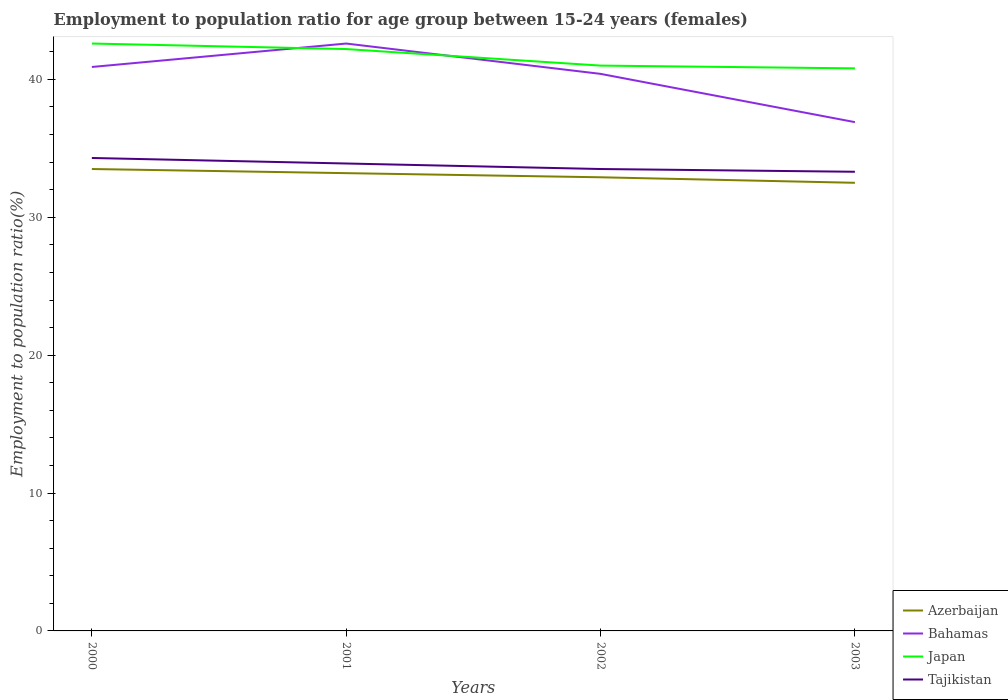How many different coloured lines are there?
Your response must be concise. 4. Does the line corresponding to Azerbaijan intersect with the line corresponding to Japan?
Provide a short and direct response. No. Is the number of lines equal to the number of legend labels?
Keep it short and to the point. Yes. Across all years, what is the maximum employment to population ratio in Bahamas?
Ensure brevity in your answer.  36.9. In which year was the employment to population ratio in Azerbaijan maximum?
Your answer should be compact. 2003. What is the total employment to population ratio in Japan in the graph?
Give a very brief answer. 1.2. What is the difference between the highest and the second highest employment to population ratio in Tajikistan?
Provide a succinct answer. 1. What is the difference between the highest and the lowest employment to population ratio in Azerbaijan?
Keep it short and to the point. 2. Is the employment to population ratio in Azerbaijan strictly greater than the employment to population ratio in Tajikistan over the years?
Your response must be concise. Yes. How many years are there in the graph?
Give a very brief answer. 4. What is the difference between two consecutive major ticks on the Y-axis?
Ensure brevity in your answer.  10. How many legend labels are there?
Your response must be concise. 4. What is the title of the graph?
Offer a terse response. Employment to population ratio for age group between 15-24 years (females). What is the label or title of the X-axis?
Provide a succinct answer. Years. What is the label or title of the Y-axis?
Make the answer very short. Employment to population ratio(%). What is the Employment to population ratio(%) in Azerbaijan in 2000?
Ensure brevity in your answer.  33.5. What is the Employment to population ratio(%) in Bahamas in 2000?
Give a very brief answer. 40.9. What is the Employment to population ratio(%) in Japan in 2000?
Make the answer very short. 42.6. What is the Employment to population ratio(%) of Tajikistan in 2000?
Give a very brief answer. 34.3. What is the Employment to population ratio(%) in Azerbaijan in 2001?
Ensure brevity in your answer.  33.2. What is the Employment to population ratio(%) of Bahamas in 2001?
Your response must be concise. 42.6. What is the Employment to population ratio(%) in Japan in 2001?
Your response must be concise. 42.2. What is the Employment to population ratio(%) of Tajikistan in 2001?
Make the answer very short. 33.9. What is the Employment to population ratio(%) in Azerbaijan in 2002?
Keep it short and to the point. 32.9. What is the Employment to population ratio(%) of Bahamas in 2002?
Offer a very short reply. 40.4. What is the Employment to population ratio(%) in Tajikistan in 2002?
Your response must be concise. 33.5. What is the Employment to population ratio(%) in Azerbaijan in 2003?
Keep it short and to the point. 32.5. What is the Employment to population ratio(%) of Bahamas in 2003?
Offer a very short reply. 36.9. What is the Employment to population ratio(%) in Japan in 2003?
Make the answer very short. 40.8. What is the Employment to population ratio(%) of Tajikistan in 2003?
Give a very brief answer. 33.3. Across all years, what is the maximum Employment to population ratio(%) in Azerbaijan?
Offer a very short reply. 33.5. Across all years, what is the maximum Employment to population ratio(%) in Bahamas?
Offer a very short reply. 42.6. Across all years, what is the maximum Employment to population ratio(%) in Japan?
Give a very brief answer. 42.6. Across all years, what is the maximum Employment to population ratio(%) in Tajikistan?
Offer a terse response. 34.3. Across all years, what is the minimum Employment to population ratio(%) in Azerbaijan?
Make the answer very short. 32.5. Across all years, what is the minimum Employment to population ratio(%) of Bahamas?
Offer a terse response. 36.9. Across all years, what is the minimum Employment to population ratio(%) of Japan?
Offer a terse response. 40.8. Across all years, what is the minimum Employment to population ratio(%) of Tajikistan?
Offer a terse response. 33.3. What is the total Employment to population ratio(%) of Azerbaijan in the graph?
Offer a terse response. 132.1. What is the total Employment to population ratio(%) in Bahamas in the graph?
Provide a short and direct response. 160.8. What is the total Employment to population ratio(%) in Japan in the graph?
Keep it short and to the point. 166.6. What is the total Employment to population ratio(%) in Tajikistan in the graph?
Provide a short and direct response. 135. What is the difference between the Employment to population ratio(%) in Japan in 2000 and that in 2001?
Your answer should be compact. 0.4. What is the difference between the Employment to population ratio(%) of Bahamas in 2000 and that in 2002?
Offer a very short reply. 0.5. What is the difference between the Employment to population ratio(%) in Tajikistan in 2000 and that in 2002?
Ensure brevity in your answer.  0.8. What is the difference between the Employment to population ratio(%) of Azerbaijan in 2000 and that in 2003?
Provide a short and direct response. 1. What is the difference between the Employment to population ratio(%) of Tajikistan in 2000 and that in 2003?
Make the answer very short. 1. What is the difference between the Employment to population ratio(%) in Azerbaijan in 2001 and that in 2002?
Keep it short and to the point. 0.3. What is the difference between the Employment to population ratio(%) of Japan in 2001 and that in 2002?
Provide a succinct answer. 1.2. What is the difference between the Employment to population ratio(%) of Tajikistan in 2001 and that in 2002?
Make the answer very short. 0.4. What is the difference between the Employment to population ratio(%) in Bahamas in 2001 and that in 2003?
Your answer should be compact. 5.7. What is the difference between the Employment to population ratio(%) of Japan in 2001 and that in 2003?
Offer a terse response. 1.4. What is the difference between the Employment to population ratio(%) of Tajikistan in 2001 and that in 2003?
Your response must be concise. 0.6. What is the difference between the Employment to population ratio(%) of Azerbaijan in 2002 and that in 2003?
Provide a short and direct response. 0.4. What is the difference between the Employment to population ratio(%) of Bahamas in 2002 and that in 2003?
Make the answer very short. 3.5. What is the difference between the Employment to population ratio(%) in Japan in 2002 and that in 2003?
Your response must be concise. 0.2. What is the difference between the Employment to population ratio(%) of Tajikistan in 2002 and that in 2003?
Offer a terse response. 0.2. What is the difference between the Employment to population ratio(%) of Azerbaijan in 2000 and the Employment to population ratio(%) of Bahamas in 2001?
Your answer should be very brief. -9.1. What is the difference between the Employment to population ratio(%) of Azerbaijan in 2000 and the Employment to population ratio(%) of Tajikistan in 2001?
Your response must be concise. -0.4. What is the difference between the Employment to population ratio(%) of Bahamas in 2000 and the Employment to population ratio(%) of Japan in 2001?
Keep it short and to the point. -1.3. What is the difference between the Employment to population ratio(%) in Azerbaijan in 2000 and the Employment to population ratio(%) in Bahamas in 2002?
Offer a very short reply. -6.9. What is the difference between the Employment to population ratio(%) of Bahamas in 2000 and the Employment to population ratio(%) of Japan in 2002?
Provide a succinct answer. -0.1. What is the difference between the Employment to population ratio(%) of Bahamas in 2000 and the Employment to population ratio(%) of Tajikistan in 2002?
Keep it short and to the point. 7.4. What is the difference between the Employment to population ratio(%) of Japan in 2000 and the Employment to population ratio(%) of Tajikistan in 2002?
Ensure brevity in your answer.  9.1. What is the difference between the Employment to population ratio(%) of Azerbaijan in 2000 and the Employment to population ratio(%) of Bahamas in 2003?
Provide a succinct answer. -3.4. What is the difference between the Employment to population ratio(%) in Bahamas in 2000 and the Employment to population ratio(%) in Tajikistan in 2003?
Give a very brief answer. 7.6. What is the difference between the Employment to population ratio(%) of Japan in 2000 and the Employment to population ratio(%) of Tajikistan in 2003?
Make the answer very short. 9.3. What is the difference between the Employment to population ratio(%) in Azerbaijan in 2001 and the Employment to population ratio(%) in Tajikistan in 2002?
Your response must be concise. -0.3. What is the difference between the Employment to population ratio(%) in Bahamas in 2001 and the Employment to population ratio(%) in Japan in 2002?
Make the answer very short. 1.6. What is the difference between the Employment to population ratio(%) of Japan in 2001 and the Employment to population ratio(%) of Tajikistan in 2002?
Ensure brevity in your answer.  8.7. What is the difference between the Employment to population ratio(%) in Azerbaijan in 2001 and the Employment to population ratio(%) in Tajikistan in 2003?
Your answer should be very brief. -0.1. What is the difference between the Employment to population ratio(%) in Bahamas in 2001 and the Employment to population ratio(%) in Japan in 2003?
Offer a very short reply. 1.8. What is the difference between the Employment to population ratio(%) of Bahamas in 2001 and the Employment to population ratio(%) of Tajikistan in 2003?
Your response must be concise. 9.3. What is the difference between the Employment to population ratio(%) in Azerbaijan in 2002 and the Employment to population ratio(%) in Bahamas in 2003?
Provide a short and direct response. -4. What is the difference between the Employment to population ratio(%) of Azerbaijan in 2002 and the Employment to population ratio(%) of Japan in 2003?
Give a very brief answer. -7.9. What is the difference between the Employment to population ratio(%) of Azerbaijan in 2002 and the Employment to population ratio(%) of Tajikistan in 2003?
Give a very brief answer. -0.4. What is the difference between the Employment to population ratio(%) in Bahamas in 2002 and the Employment to population ratio(%) in Japan in 2003?
Provide a short and direct response. -0.4. What is the difference between the Employment to population ratio(%) in Bahamas in 2002 and the Employment to population ratio(%) in Tajikistan in 2003?
Ensure brevity in your answer.  7.1. What is the average Employment to population ratio(%) in Azerbaijan per year?
Keep it short and to the point. 33.02. What is the average Employment to population ratio(%) of Bahamas per year?
Give a very brief answer. 40.2. What is the average Employment to population ratio(%) in Japan per year?
Provide a succinct answer. 41.65. What is the average Employment to population ratio(%) of Tajikistan per year?
Keep it short and to the point. 33.75. In the year 2000, what is the difference between the Employment to population ratio(%) of Azerbaijan and Employment to population ratio(%) of Tajikistan?
Give a very brief answer. -0.8. In the year 2000, what is the difference between the Employment to population ratio(%) in Bahamas and Employment to population ratio(%) in Japan?
Offer a very short reply. -1.7. In the year 2000, what is the difference between the Employment to population ratio(%) of Japan and Employment to population ratio(%) of Tajikistan?
Offer a terse response. 8.3. In the year 2001, what is the difference between the Employment to population ratio(%) of Azerbaijan and Employment to population ratio(%) of Bahamas?
Give a very brief answer. -9.4. In the year 2001, what is the difference between the Employment to population ratio(%) of Azerbaijan and Employment to population ratio(%) of Japan?
Give a very brief answer. -9. In the year 2002, what is the difference between the Employment to population ratio(%) in Azerbaijan and Employment to population ratio(%) in Japan?
Provide a short and direct response. -8.1. In the year 2002, what is the difference between the Employment to population ratio(%) in Azerbaijan and Employment to population ratio(%) in Tajikistan?
Provide a short and direct response. -0.6. In the year 2002, what is the difference between the Employment to population ratio(%) of Bahamas and Employment to population ratio(%) of Japan?
Give a very brief answer. -0.6. In the year 2002, what is the difference between the Employment to population ratio(%) of Bahamas and Employment to population ratio(%) of Tajikistan?
Ensure brevity in your answer.  6.9. In the year 2003, what is the difference between the Employment to population ratio(%) of Azerbaijan and Employment to population ratio(%) of Bahamas?
Offer a very short reply. -4.4. In the year 2003, what is the difference between the Employment to population ratio(%) in Bahamas and Employment to population ratio(%) in Japan?
Keep it short and to the point. -3.9. In the year 2003, what is the difference between the Employment to population ratio(%) of Bahamas and Employment to population ratio(%) of Tajikistan?
Give a very brief answer. 3.6. What is the ratio of the Employment to population ratio(%) of Azerbaijan in 2000 to that in 2001?
Give a very brief answer. 1.01. What is the ratio of the Employment to population ratio(%) of Bahamas in 2000 to that in 2001?
Ensure brevity in your answer.  0.96. What is the ratio of the Employment to population ratio(%) of Japan in 2000 to that in 2001?
Offer a terse response. 1.01. What is the ratio of the Employment to population ratio(%) in Tajikistan in 2000 to that in 2001?
Offer a terse response. 1.01. What is the ratio of the Employment to population ratio(%) in Azerbaijan in 2000 to that in 2002?
Make the answer very short. 1.02. What is the ratio of the Employment to population ratio(%) of Bahamas in 2000 to that in 2002?
Offer a very short reply. 1.01. What is the ratio of the Employment to population ratio(%) of Japan in 2000 to that in 2002?
Your response must be concise. 1.04. What is the ratio of the Employment to population ratio(%) of Tajikistan in 2000 to that in 2002?
Provide a succinct answer. 1.02. What is the ratio of the Employment to population ratio(%) in Azerbaijan in 2000 to that in 2003?
Your response must be concise. 1.03. What is the ratio of the Employment to population ratio(%) in Bahamas in 2000 to that in 2003?
Ensure brevity in your answer.  1.11. What is the ratio of the Employment to population ratio(%) of Japan in 2000 to that in 2003?
Give a very brief answer. 1.04. What is the ratio of the Employment to population ratio(%) of Azerbaijan in 2001 to that in 2002?
Provide a succinct answer. 1.01. What is the ratio of the Employment to population ratio(%) in Bahamas in 2001 to that in 2002?
Offer a terse response. 1.05. What is the ratio of the Employment to population ratio(%) in Japan in 2001 to that in 2002?
Offer a terse response. 1.03. What is the ratio of the Employment to population ratio(%) of Tajikistan in 2001 to that in 2002?
Offer a terse response. 1.01. What is the ratio of the Employment to population ratio(%) of Azerbaijan in 2001 to that in 2003?
Provide a succinct answer. 1.02. What is the ratio of the Employment to population ratio(%) of Bahamas in 2001 to that in 2003?
Your answer should be very brief. 1.15. What is the ratio of the Employment to population ratio(%) of Japan in 2001 to that in 2003?
Give a very brief answer. 1.03. What is the ratio of the Employment to population ratio(%) of Azerbaijan in 2002 to that in 2003?
Provide a succinct answer. 1.01. What is the ratio of the Employment to population ratio(%) of Bahamas in 2002 to that in 2003?
Provide a succinct answer. 1.09. What is the ratio of the Employment to population ratio(%) in Japan in 2002 to that in 2003?
Provide a short and direct response. 1. What is the difference between the highest and the second highest Employment to population ratio(%) in Bahamas?
Provide a succinct answer. 1.7. What is the difference between the highest and the second highest Employment to population ratio(%) in Japan?
Give a very brief answer. 0.4. What is the difference between the highest and the lowest Employment to population ratio(%) of Azerbaijan?
Ensure brevity in your answer.  1. What is the difference between the highest and the lowest Employment to population ratio(%) in Japan?
Keep it short and to the point. 1.8. 